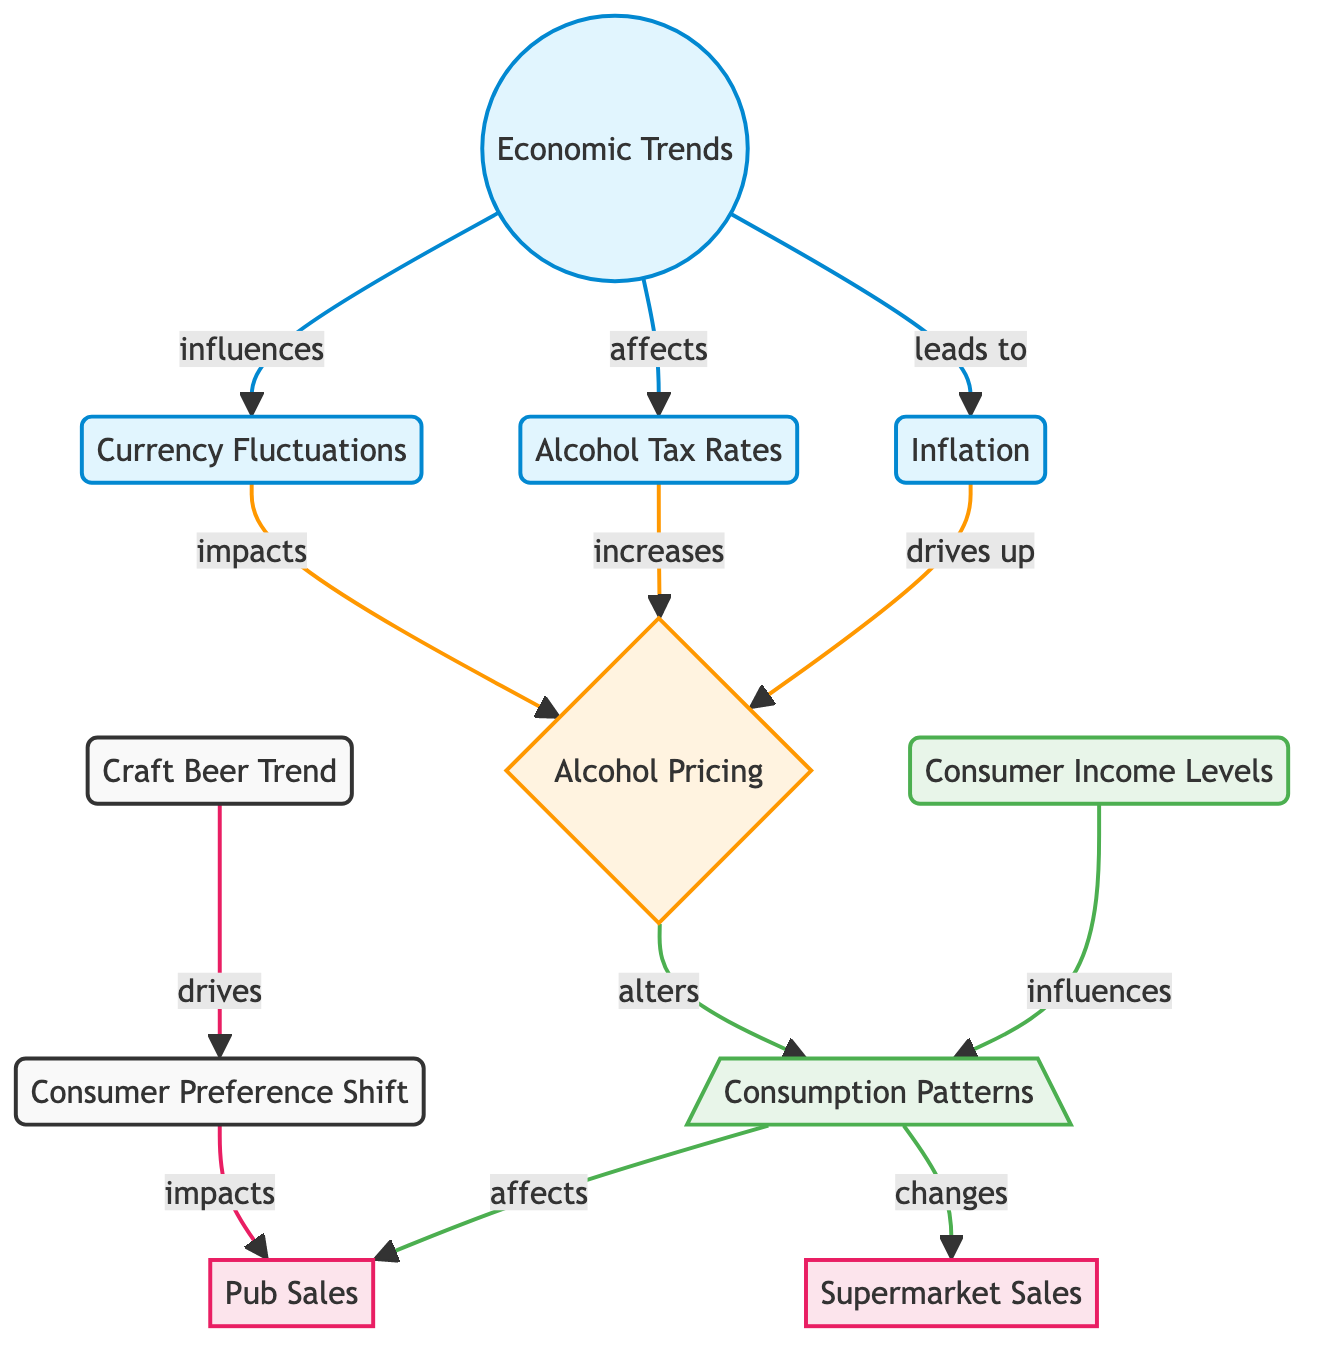what nodes are connected to economic trends? The diagram shows three nodes connected to "Economic Trends": "Inflation", "Alcohol Tax Rates", and "Currency Fluctuations". This can be identified by following the arrows leading out from the "Economic Trends" node.
Answer: Inflation, Alcohol Tax Rates, Currency Fluctuations how many edges are leading out from the alcohol pricing node? The "Alcohol Pricing" node has three edges leading outwards: one to "Consumption Patterns", one to "Pub Sales", and one to "Supermarket Sales". By counting the arrows emanating from this node, we find that there are three connections.
Answer: 3 what drives the consumer preference shift? The diagram indicates that the "Craft Beer Trend" drives the "Consumer Preference Shift". This is shown by the arrow leading from "Craft Beer Trend" to "Consumer Preference Shift".
Answer: Craft Beer Trend which node influences the pub sales? "Consumption Patterns" directly affects "Pub Sales" as indicated by the arrow leading from "Consumption Patterns" to "Pub Sales". This relationship shows that changes in consumption patterns will result in changes in pub sales.
Answer: Consumption Patterns what is the relationship between inflation and alcohol pricing? The relationship is that "Inflation" drives up "Alcohol Pricing". This is represented in the diagram by the arrow pointing from "Inflation" to "Alcohol Pricing", indicating a direct influence.
Answer: drives up how does consumer income affect consumption patterns? "Consumer Income Levels" influences "Consumption Patterns" by impacting purchasing power and drinking habits, as shown in the diagram by the arrow from "Consumer Income Levels" to "Consumption Patterns". This means changes in consumer income will affect how people consume alcohol.
Answer: influences how many factors are shown to impact alcohol pricing? There are three factors indicated to impact "Alcohol Pricing": "Inflation", "Alcohol Tax Rates", and "Currency Fluctuations". By reviewing the connections leading into "Alcohol Pricing", we identify these three contributing factors.
Answer: 3 which factors have a direct effect on pub sales? The factors are "Consumption Patterns" and "Consumer Preference Shift". "Consumption Patterns" affects pub sales, as illustrated by the direct arrow, and "Consumer Preference Shift" also impacts pub sales. Both influences are represented with directional arrows leading to "Pub Sales".
Answer: Consumption Patterns, Consumer Preference Shift What is the subsequent effect of tax rates on alcohol pricing? The diagram illustrates that "Tax Rates" increases "Alcohol Pricing". This relationship is shown through the arrow flowing from "Tax Rates" to "Alcohol Pricing", indicating a direct causal effect.
Answer: increases 